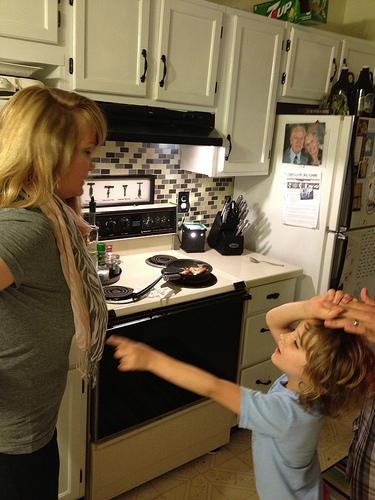Question: why is little boy pointing?
Choices:
A. To show a dog.
B. He sees a cat.
C. He sees a frog.
D. He wants something.
Answer with the letter. Answer: D Question: what is third person doing?
Choices:
A. Flying a kite.
B. Gardening.
C. Sewing.
D. Holding the boys hand.
Answer with the letter. Answer: D Question: when was picture taken?
Choices:
A. Sunset.
B. Dusk.
C. During daylight.
D. Midnight.
Answer with the letter. Answer: C Question: what is off to right side?
Choices:
A. A refrigerator.
B. A stove.
C. An oven.
D. A fireplace.
Answer with the letter. Answer: A Question: what is this?
Choices:
A. A spoon.
B. A kitchen.
C. A fork.
D. A knife.
Answer with the letter. Answer: B Question: how many people in picture?
Choices:
A. Four.
B. Two.
C. Five.
D. Three.
Answer with the letter. Answer: D Question: where is stove?
Choices:
A. Beside refrigerator.
B. In the kitchen.
C. In the camper.
D. By the sink.
Answer with the letter. Answer: A 